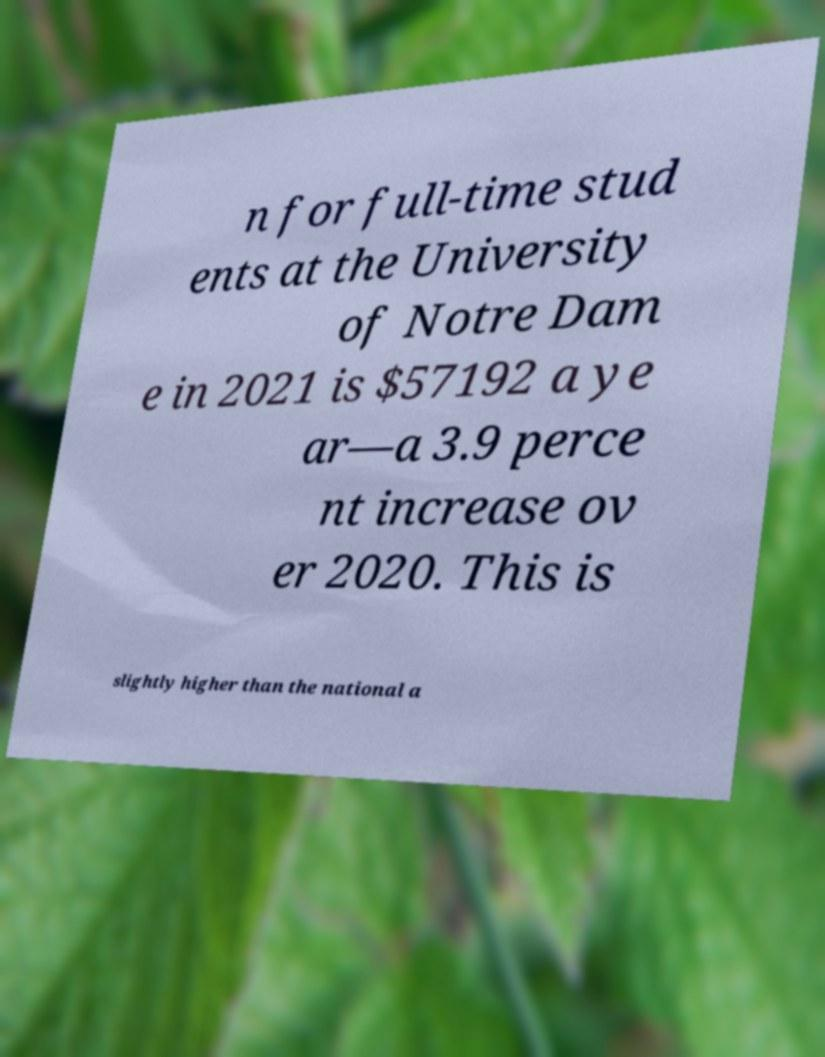Please identify and transcribe the text found in this image. n for full-time stud ents at the University of Notre Dam e in 2021 is $57192 a ye ar—a 3.9 perce nt increase ov er 2020. This is slightly higher than the national a 